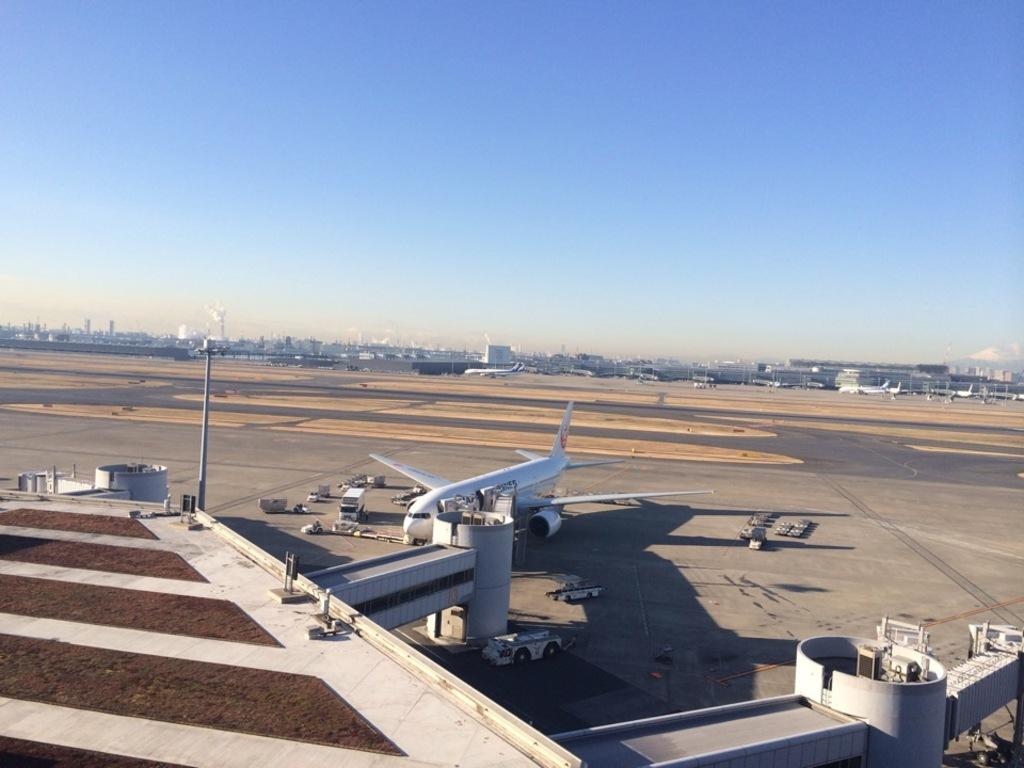What is the main subject of the image? The main subject of the image is an aeroplane. What other objects can be seen in the image? There are vehicles and pillars visible in the image. What is the pole used for in the image? The purpose of the pole is not clear from the image, but it could be used for signage or lighting. What can be seen in the background of the image? There are buildings and vehicles in the background of the image. What is the condition of the sky in the image? The sky is clear and visible at the top of the image. What type of food is being served in the image? There is no food present in the image. What kind of flowers can be seen growing near the aeroplane? There are no flowers visible in the image. 